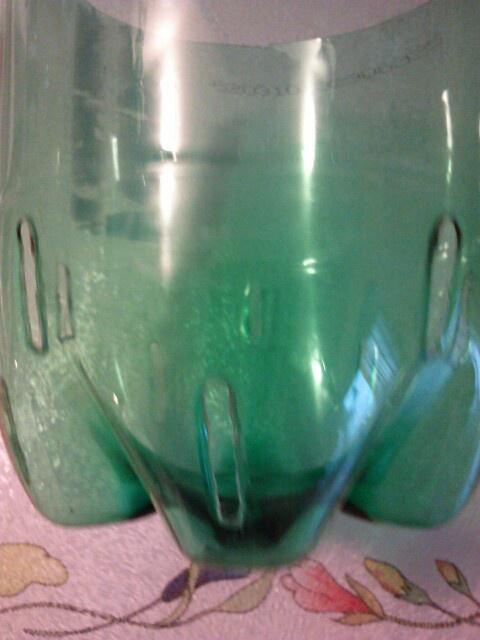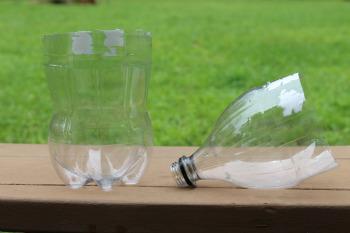The first image is the image on the left, the second image is the image on the right. Assess this claim about the two images: "The top of the bottle is sitting next to the bottom in one of the images.". Correct or not? Answer yes or no. Yes. The first image is the image on the left, the second image is the image on the right. Analyze the images presented: Is the assertion "In at least one image there is a green soda bottle cut in to two pieces." valid? Answer yes or no. No. 